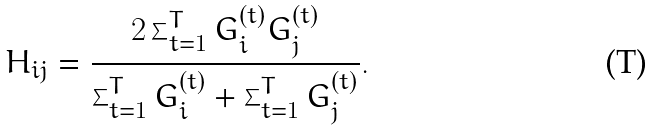<formula> <loc_0><loc_0><loc_500><loc_500>H _ { i j } = \frac { 2 \sum _ { t = 1 } ^ { T } G _ { i } ^ { ( t ) } G _ { j } ^ { ( t ) } } { \sum _ { t = 1 } ^ { T } G _ { i } ^ { ( t ) } + \sum _ { t = 1 } ^ { T } G _ { j } ^ { ( t ) } } .</formula> 